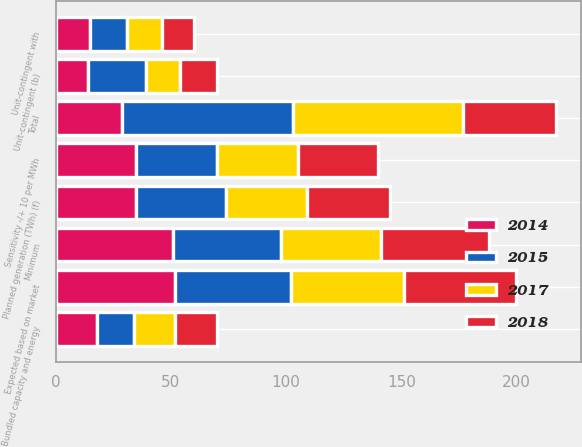<chart> <loc_0><loc_0><loc_500><loc_500><stacked_bar_chart><ecel><fcel>Unit-contingent (b)<fcel>Unit-contingent with<fcel>Total<fcel>Planned generation (TWh) (f)<fcel>Minimum<fcel>Expected based on market<fcel>Sensitivity -/+ 10 per MWh<fcel>Bundled capacity and energy<nl><fcel>2015<fcel>25<fcel>16<fcel>74<fcel>39<fcel>47<fcel>50<fcel>35<fcel>16<nl><fcel>2017<fcel>15<fcel>15<fcel>74<fcel>35<fcel>43<fcel>49<fcel>35<fcel>18<nl><fcel>2018<fcel>16<fcel>14<fcel>40<fcel>36<fcel>47<fcel>49<fcel>35<fcel>18<nl><fcel>2014<fcel>14<fcel>15<fcel>29<fcel>35<fcel>51<fcel>52<fcel>35<fcel>18<nl></chart> 